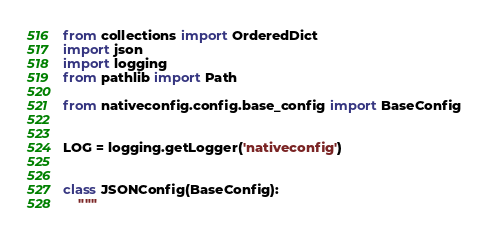Convert code to text. <code><loc_0><loc_0><loc_500><loc_500><_Python_>from collections import OrderedDict
import json
import logging
from pathlib import Path

from nativeconfig.config.base_config import BaseConfig


LOG = logging.getLogger('nativeconfig')


class JSONConfig(BaseConfig):
    """</code> 